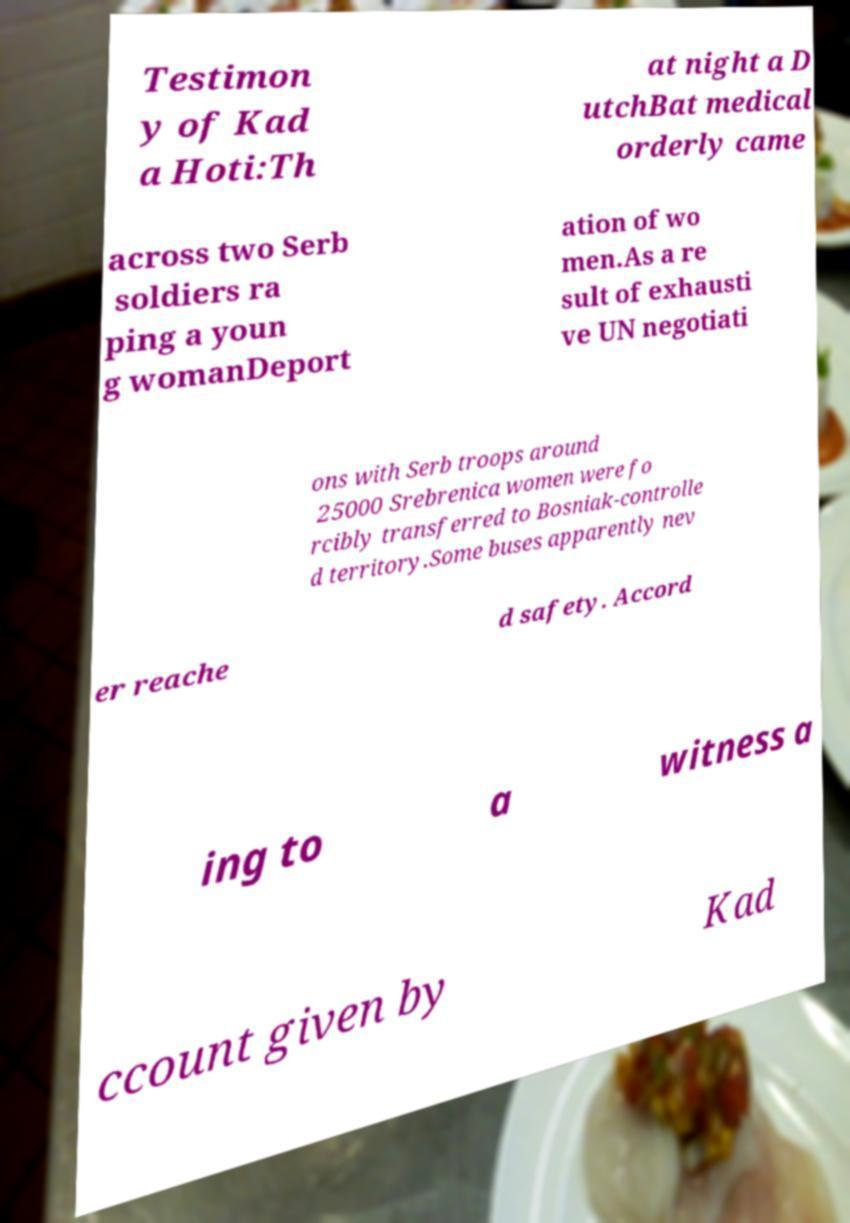What messages or text are displayed in this image? I need them in a readable, typed format. Testimon y of Kad a Hoti:Th at night a D utchBat medical orderly came across two Serb soldiers ra ping a youn g womanDeport ation of wo men.As a re sult of exhausti ve UN negotiati ons with Serb troops around 25000 Srebrenica women were fo rcibly transferred to Bosniak-controlle d territory.Some buses apparently nev er reache d safety. Accord ing to a witness a ccount given by Kad 